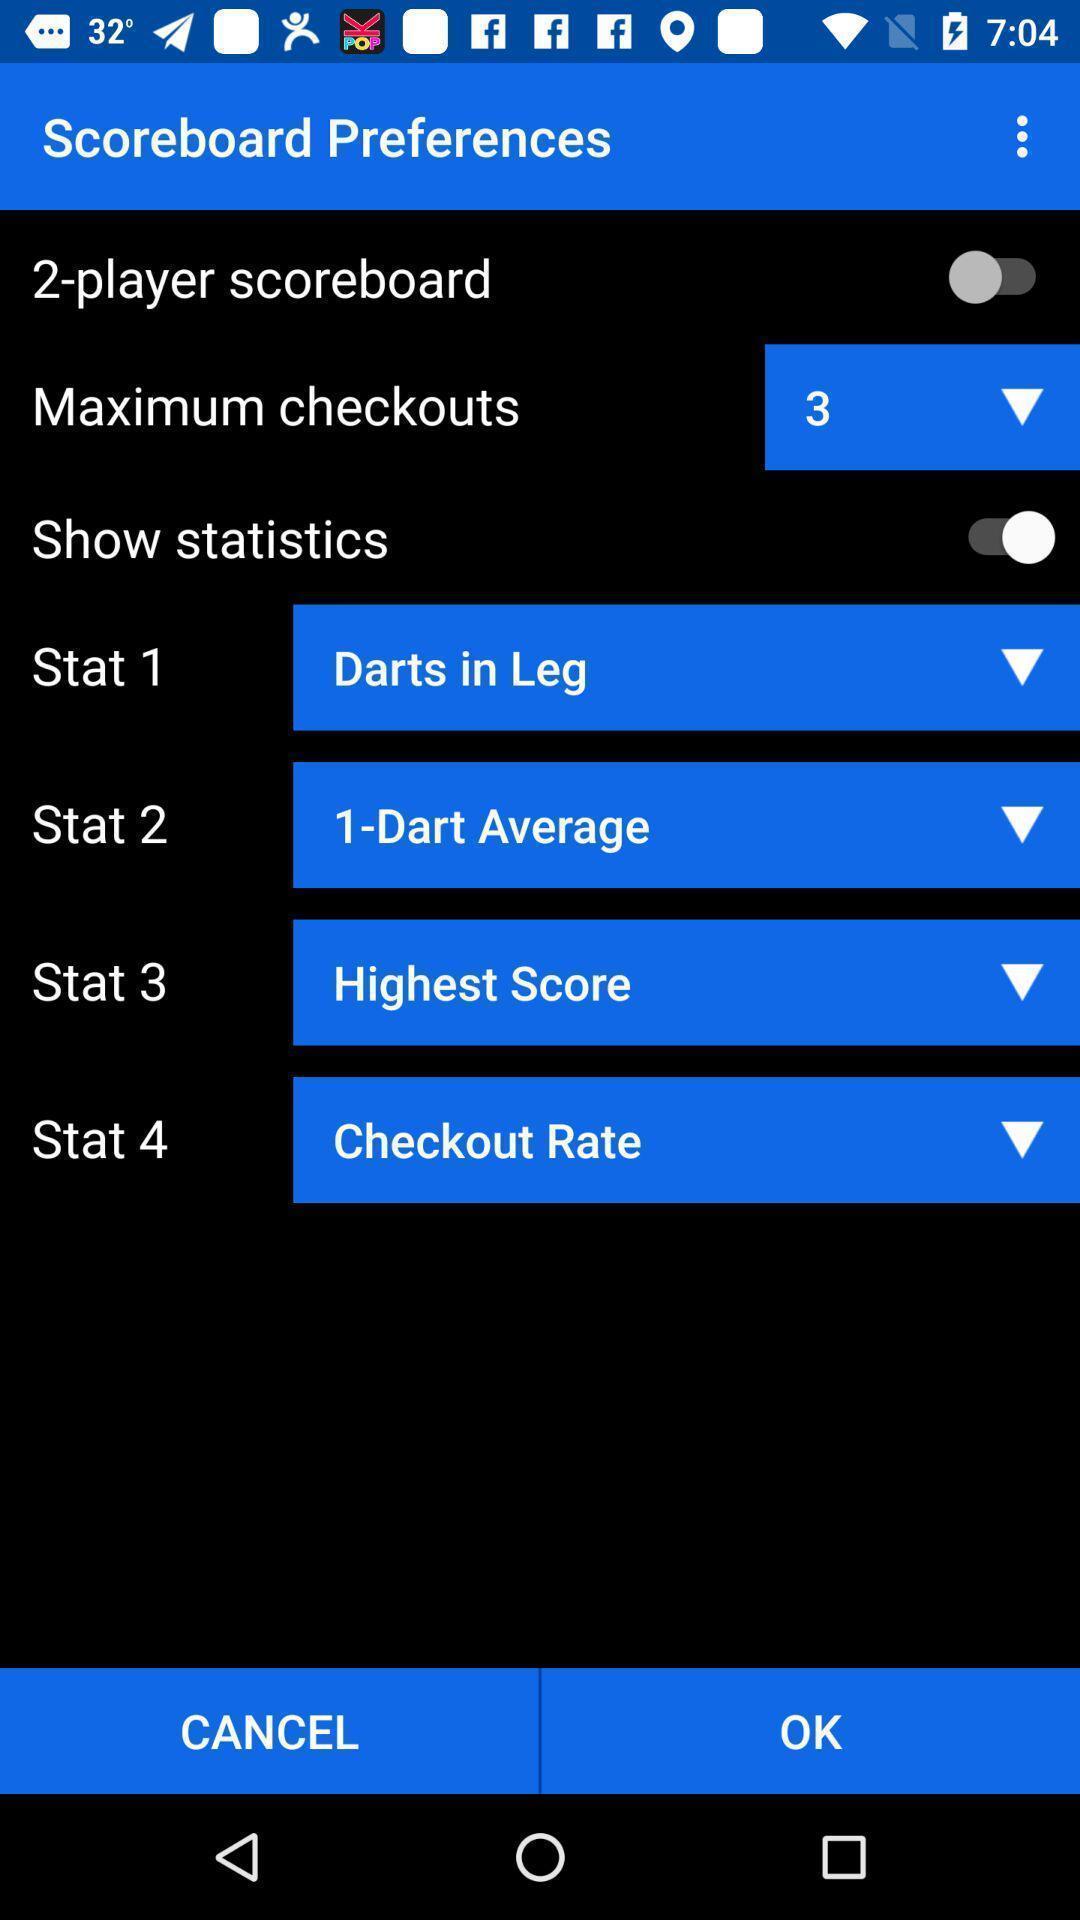What details can you identify in this image? Screen shows scoreboard details in a gaming app. 